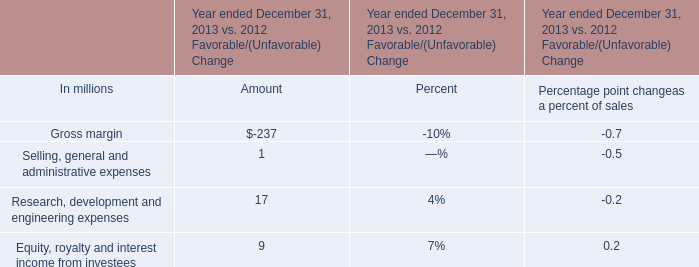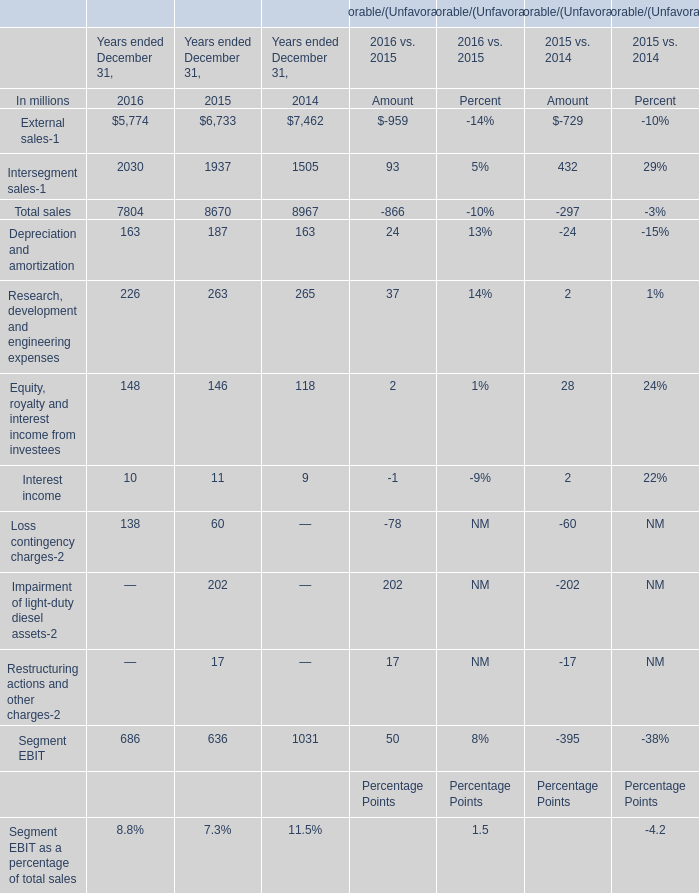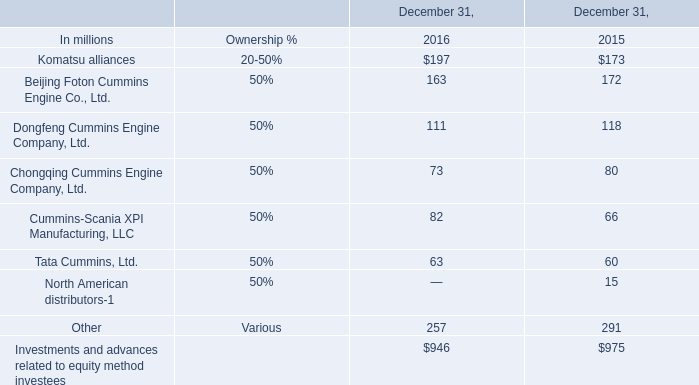What's the average of the Total sales in the years where Tata Cummins, Ltd. is greater than 0? (in million) 
Computations: ((7804 + 8670) / 2)
Answer: 8237.0. 